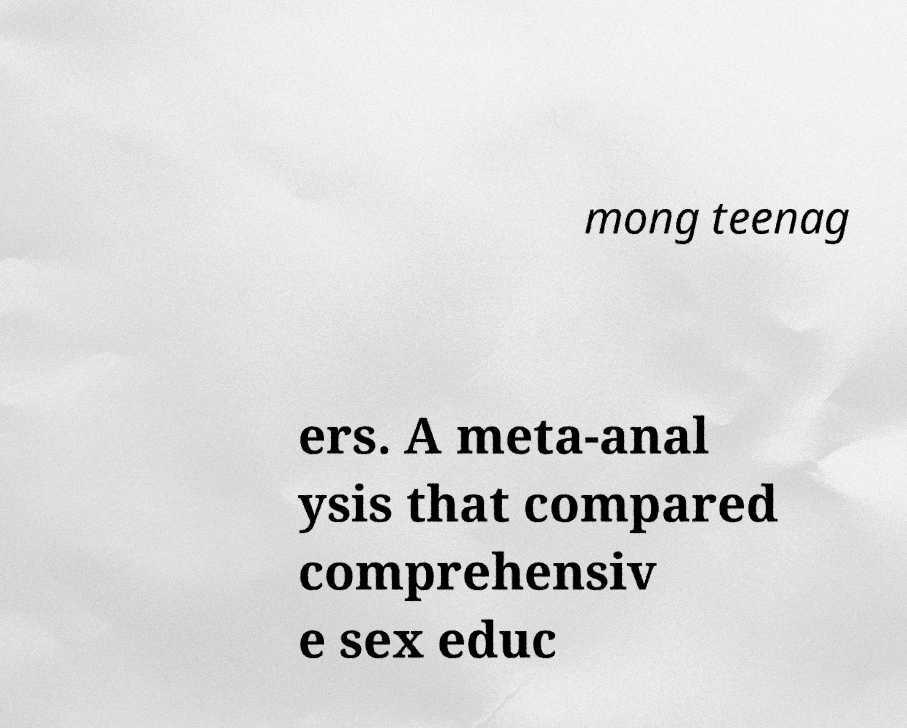Please identify and transcribe the text found in this image. mong teenag ers. A meta-anal ysis that compared comprehensiv e sex educ 